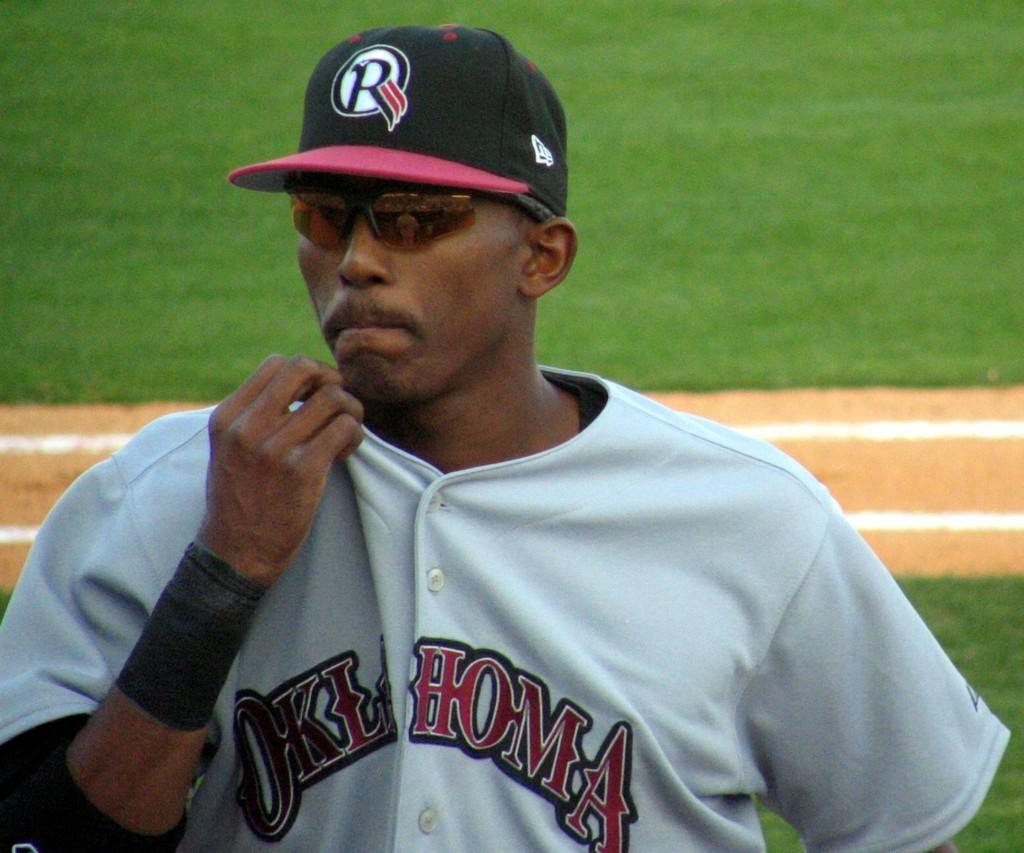<image>
Relay a brief, clear account of the picture shown. A player for Oklahoma is wearing sunglasses and pulling at his shirt collar. 